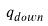Convert formula to latex. <formula><loc_0><loc_0><loc_500><loc_500>\ q _ { d o w n }</formula> 